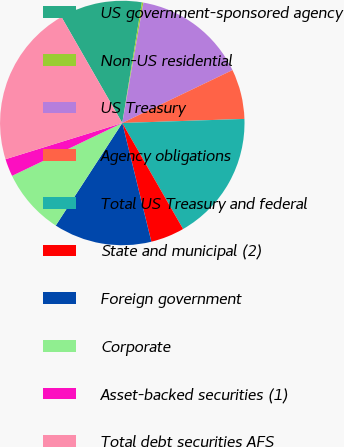<chart> <loc_0><loc_0><loc_500><loc_500><pie_chart><fcel>US government-sponsored agency<fcel>Non-US residential<fcel>US Treasury<fcel>Agency obligations<fcel>Total US Treasury and federal<fcel>State and municipal (2)<fcel>Foreign government<fcel>Corporate<fcel>Asset-backed securities (1)<fcel>Total debt securities AFS<nl><fcel>10.85%<fcel>0.2%<fcel>15.11%<fcel>6.59%<fcel>17.24%<fcel>4.46%<fcel>12.98%<fcel>8.72%<fcel>2.33%<fcel>21.49%<nl></chart> 